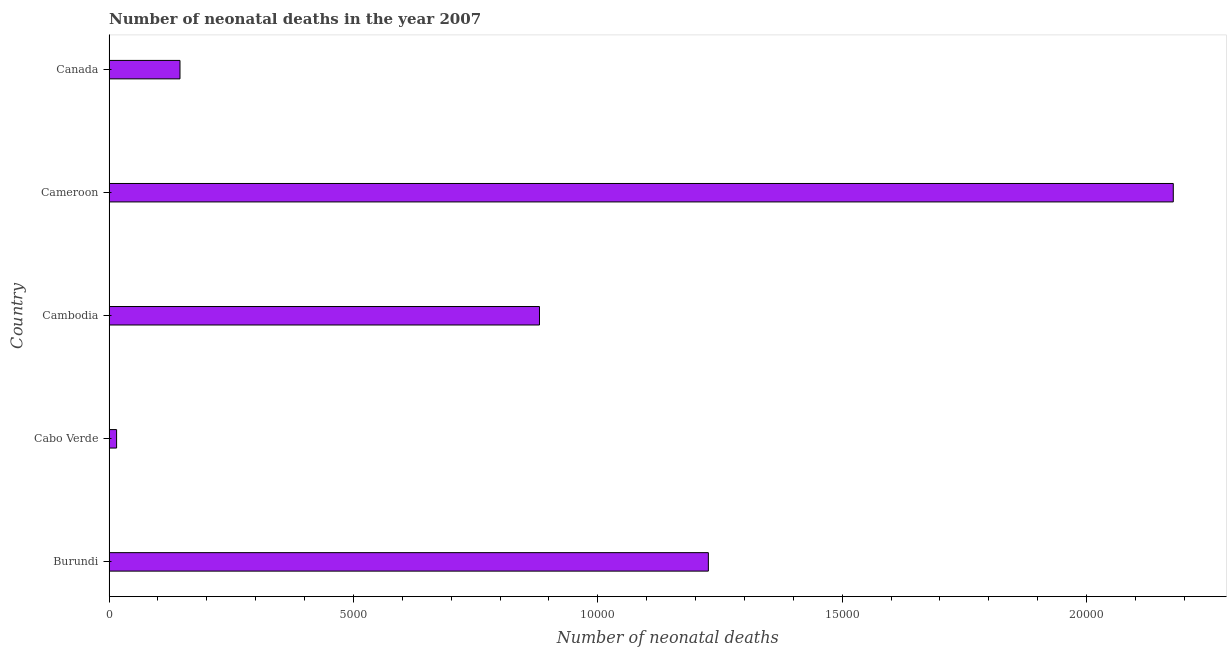What is the title of the graph?
Ensure brevity in your answer.  Number of neonatal deaths in the year 2007. What is the label or title of the X-axis?
Your answer should be very brief. Number of neonatal deaths. What is the label or title of the Y-axis?
Make the answer very short. Country. What is the number of neonatal deaths in Burundi?
Give a very brief answer. 1.23e+04. Across all countries, what is the maximum number of neonatal deaths?
Provide a short and direct response. 2.18e+04. Across all countries, what is the minimum number of neonatal deaths?
Offer a very short reply. 154. In which country was the number of neonatal deaths maximum?
Your answer should be very brief. Cameroon. In which country was the number of neonatal deaths minimum?
Your answer should be very brief. Cabo Verde. What is the sum of the number of neonatal deaths?
Make the answer very short. 4.44e+04. What is the difference between the number of neonatal deaths in Cabo Verde and Cameroon?
Offer a terse response. -2.16e+04. What is the average number of neonatal deaths per country?
Make the answer very short. 8889. What is the median number of neonatal deaths?
Your response must be concise. 8806. What is the ratio of the number of neonatal deaths in Cabo Verde to that in Cameroon?
Your answer should be very brief. 0.01. Is the difference between the number of neonatal deaths in Cabo Verde and Cameroon greater than the difference between any two countries?
Provide a succinct answer. Yes. What is the difference between the highest and the second highest number of neonatal deaths?
Your answer should be very brief. 9512. What is the difference between the highest and the lowest number of neonatal deaths?
Your answer should be compact. 2.16e+04. In how many countries, is the number of neonatal deaths greater than the average number of neonatal deaths taken over all countries?
Make the answer very short. 2. Are all the bars in the graph horizontal?
Give a very brief answer. Yes. How many countries are there in the graph?
Your answer should be very brief. 5. What is the difference between two consecutive major ticks on the X-axis?
Ensure brevity in your answer.  5000. Are the values on the major ticks of X-axis written in scientific E-notation?
Offer a very short reply. No. What is the Number of neonatal deaths of Burundi?
Provide a succinct answer. 1.23e+04. What is the Number of neonatal deaths in Cabo Verde?
Your answer should be very brief. 154. What is the Number of neonatal deaths in Cambodia?
Your answer should be compact. 8806. What is the Number of neonatal deaths in Cameroon?
Keep it short and to the point. 2.18e+04. What is the Number of neonatal deaths in Canada?
Provide a short and direct response. 1451. What is the difference between the Number of neonatal deaths in Burundi and Cabo Verde?
Ensure brevity in your answer.  1.21e+04. What is the difference between the Number of neonatal deaths in Burundi and Cambodia?
Offer a very short reply. 3455. What is the difference between the Number of neonatal deaths in Burundi and Cameroon?
Offer a very short reply. -9512. What is the difference between the Number of neonatal deaths in Burundi and Canada?
Provide a short and direct response. 1.08e+04. What is the difference between the Number of neonatal deaths in Cabo Verde and Cambodia?
Ensure brevity in your answer.  -8652. What is the difference between the Number of neonatal deaths in Cabo Verde and Cameroon?
Your response must be concise. -2.16e+04. What is the difference between the Number of neonatal deaths in Cabo Verde and Canada?
Offer a very short reply. -1297. What is the difference between the Number of neonatal deaths in Cambodia and Cameroon?
Your response must be concise. -1.30e+04. What is the difference between the Number of neonatal deaths in Cambodia and Canada?
Make the answer very short. 7355. What is the difference between the Number of neonatal deaths in Cameroon and Canada?
Give a very brief answer. 2.03e+04. What is the ratio of the Number of neonatal deaths in Burundi to that in Cabo Verde?
Give a very brief answer. 79.62. What is the ratio of the Number of neonatal deaths in Burundi to that in Cambodia?
Your answer should be very brief. 1.39. What is the ratio of the Number of neonatal deaths in Burundi to that in Cameroon?
Your answer should be compact. 0.56. What is the ratio of the Number of neonatal deaths in Burundi to that in Canada?
Provide a succinct answer. 8.45. What is the ratio of the Number of neonatal deaths in Cabo Verde to that in Cambodia?
Make the answer very short. 0.02. What is the ratio of the Number of neonatal deaths in Cabo Verde to that in Cameroon?
Offer a terse response. 0.01. What is the ratio of the Number of neonatal deaths in Cabo Verde to that in Canada?
Your answer should be very brief. 0.11. What is the ratio of the Number of neonatal deaths in Cambodia to that in Cameroon?
Give a very brief answer. 0.4. What is the ratio of the Number of neonatal deaths in Cambodia to that in Canada?
Provide a short and direct response. 6.07. What is the ratio of the Number of neonatal deaths in Cameroon to that in Canada?
Offer a very short reply. 15.01. 